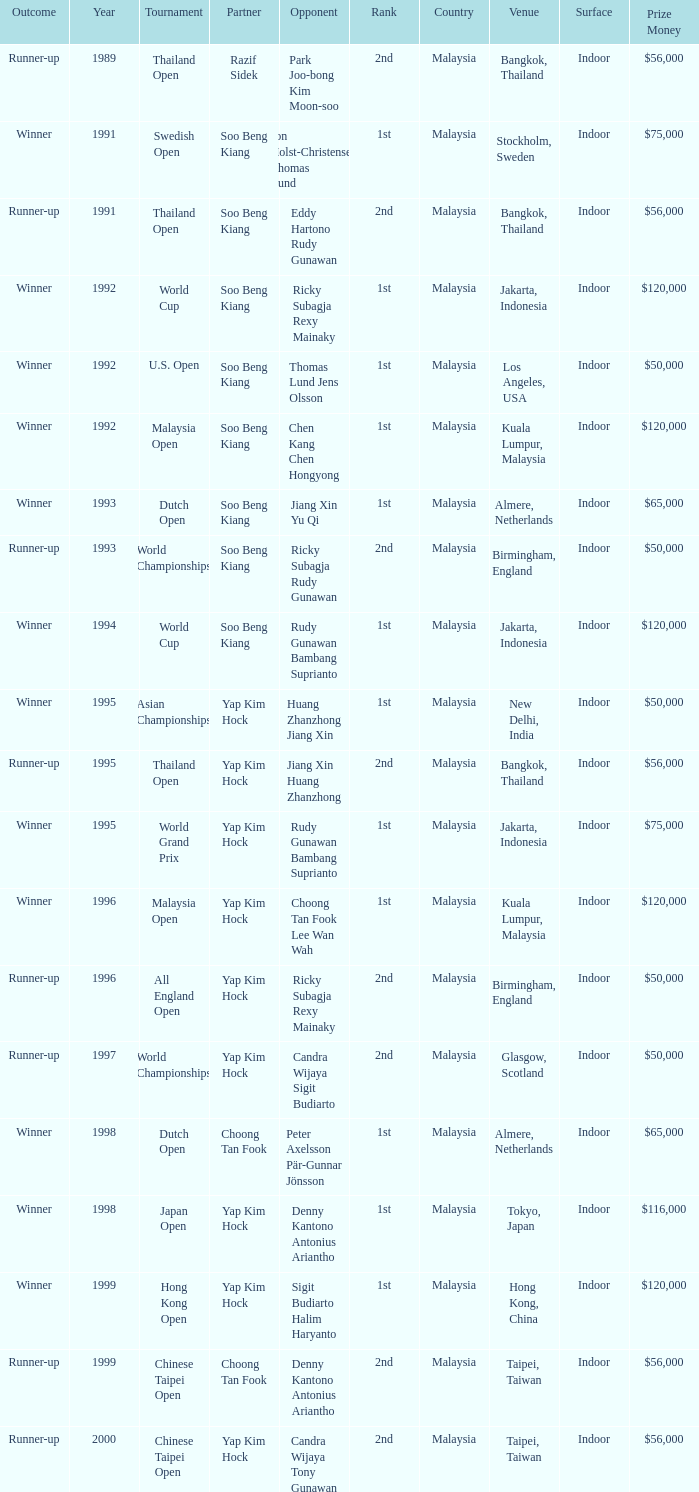Who was Choong Tan Fook's opponent in 1999? Denny Kantono Antonius Ariantho. 